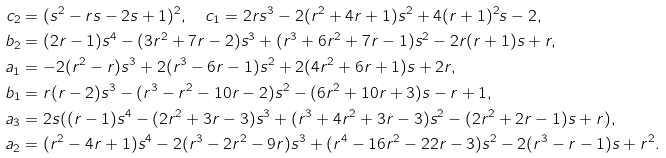Convert formula to latex. <formula><loc_0><loc_0><loc_500><loc_500>c _ { 2 } & = ( s ^ { 2 } - r s - 2 s + 1 ) ^ { 2 } , \quad c _ { 1 } = 2 r s ^ { 3 } - 2 ( r ^ { 2 } + 4 r + 1 ) s ^ { 2 } + 4 ( r + 1 ) ^ { 2 } s - 2 , \\ b _ { 2 } & = ( 2 r - 1 ) s ^ { 4 } - ( 3 r ^ { 2 } + 7 r - 2 ) s ^ { 3 } + ( r ^ { 3 } + 6 r ^ { 2 } + 7 r - 1 ) s ^ { 2 } - 2 r ( r + 1 ) s + r , \\ a _ { 1 } & = - 2 ( r ^ { 2 } - r ) s ^ { 3 } + 2 ( r ^ { 3 } - 6 r - 1 ) s ^ { 2 } + 2 ( 4 r ^ { 2 } + 6 r + 1 ) s + 2 r , \\ b _ { 1 } & = r ( r - 2 ) s ^ { 3 } - ( r ^ { 3 } - r ^ { 2 } - 1 0 r - 2 ) s ^ { 2 } - ( 6 r ^ { 2 } + 1 0 r + 3 ) s - r + 1 , \\ a _ { 3 } & = 2 s ( ( r - 1 ) s ^ { 4 } - ( 2 r ^ { 2 } + 3 r - 3 ) s ^ { 3 } + ( r ^ { 3 } + 4 r ^ { 2 } + 3 r - 3 ) s ^ { 2 } - ( 2 r ^ { 2 } + 2 r - 1 ) s + r ) , \\ a _ { 2 } & = ( r ^ { 2 } - 4 r + 1 ) s ^ { 4 } - 2 ( r ^ { 3 } - 2 r ^ { 2 } - 9 r ) s ^ { 3 } + ( r ^ { 4 } - 1 6 r ^ { 2 } - 2 2 r - 3 ) s ^ { 2 } - 2 ( r ^ { 3 } - r - 1 ) s + r ^ { 2 } .</formula> 